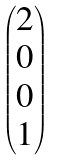<formula> <loc_0><loc_0><loc_500><loc_500>\begin{pmatrix} 2 \\ 0 \\ 0 \\ 1 \end{pmatrix}</formula> 